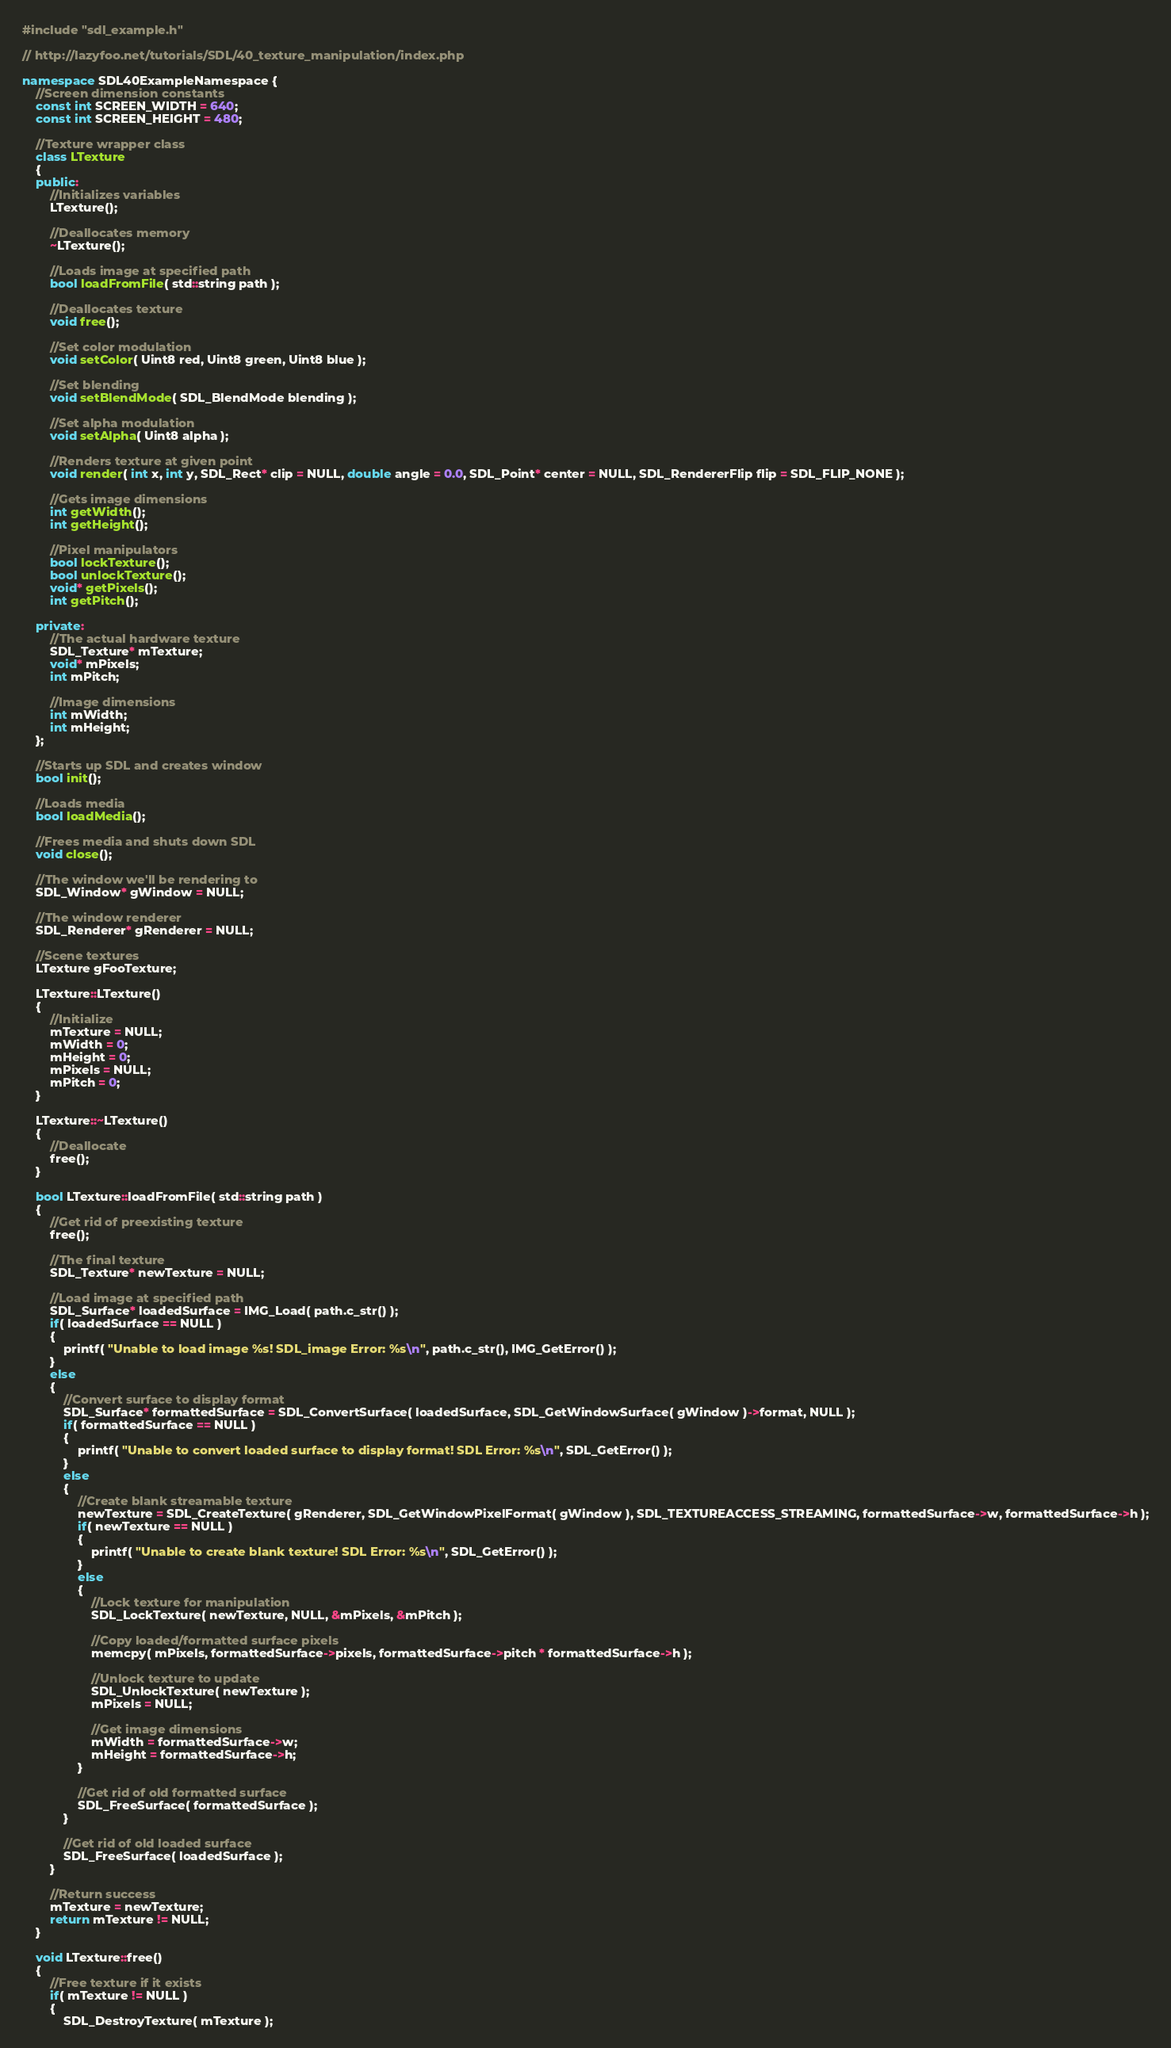Convert code to text. <code><loc_0><loc_0><loc_500><loc_500><_C++_>
#include "sdl_example.h"

// http://lazyfoo.net/tutorials/SDL/40_texture_manipulation/index.php

namespace SDL40ExampleNamespace {
    //Screen dimension constants
    const int SCREEN_WIDTH = 640;
    const int SCREEN_HEIGHT = 480;

    //Texture wrapper class
    class LTexture
    {
    public:
        //Initializes variables
        LTexture();

        //Deallocates memory
        ~LTexture();

        //Loads image at specified path
        bool loadFromFile( std::string path );

        //Deallocates texture
        void free();

        //Set color modulation
        void setColor( Uint8 red, Uint8 green, Uint8 blue );

        //Set blending
        void setBlendMode( SDL_BlendMode blending );

        //Set alpha modulation
        void setAlpha( Uint8 alpha );

        //Renders texture at given point
        void render( int x, int y, SDL_Rect* clip = NULL, double angle = 0.0, SDL_Point* center = NULL, SDL_RendererFlip flip = SDL_FLIP_NONE );

        //Gets image dimensions
        int getWidth();
        int getHeight();

        //Pixel manipulators
        bool lockTexture();
        bool unlockTexture();
        void* getPixels();
        int getPitch();

    private:
        //The actual hardware texture
        SDL_Texture* mTexture;
        void* mPixels;
        int mPitch;

        //Image dimensions
        int mWidth;
        int mHeight;
    };

    //Starts up SDL and creates window
    bool init();

    //Loads media
    bool loadMedia();

    //Frees media and shuts down SDL
    void close();

    //The window we'll be rendering to
    SDL_Window* gWindow = NULL;

    //The window renderer
    SDL_Renderer* gRenderer = NULL;

    //Scene textures
    LTexture gFooTexture;

    LTexture::LTexture()
    {
        //Initialize
        mTexture = NULL;
        mWidth = 0;
        mHeight = 0;
        mPixels = NULL;
        mPitch = 0;
    }

    LTexture::~LTexture()
    {
        //Deallocate
        free();
    }

    bool LTexture::loadFromFile( std::string path )
    {
        //Get rid of preexisting texture
        free();

        //The final texture
        SDL_Texture* newTexture = NULL;

        //Load image at specified path
        SDL_Surface* loadedSurface = IMG_Load( path.c_str() );
        if( loadedSurface == NULL )
        {
            printf( "Unable to load image %s! SDL_image Error: %s\n", path.c_str(), IMG_GetError() );
        }
        else
        {
            //Convert surface to display format
            SDL_Surface* formattedSurface = SDL_ConvertSurface( loadedSurface, SDL_GetWindowSurface( gWindow )->format, NULL );
            if( formattedSurface == NULL )
            {
                printf( "Unable to convert loaded surface to display format! SDL Error: %s\n", SDL_GetError() );
            }
            else
            {
                //Create blank streamable texture
                newTexture = SDL_CreateTexture( gRenderer, SDL_GetWindowPixelFormat( gWindow ), SDL_TEXTUREACCESS_STREAMING, formattedSurface->w, formattedSurface->h );
                if( newTexture == NULL )
                {
                    printf( "Unable to create blank texture! SDL Error: %s\n", SDL_GetError() );
                }
                else
                {
                    //Lock texture for manipulation
                    SDL_LockTexture( newTexture, NULL, &mPixels, &mPitch );

                    //Copy loaded/formatted surface pixels
                    memcpy( mPixels, formattedSurface->pixels, formattedSurface->pitch * formattedSurface->h );

                    //Unlock texture to update
                    SDL_UnlockTexture( newTexture );
                    mPixels = NULL;

                    //Get image dimensions
                    mWidth = formattedSurface->w;
                    mHeight = formattedSurface->h;
                }

                //Get rid of old formatted surface
                SDL_FreeSurface( formattedSurface );
            }

            //Get rid of old loaded surface
            SDL_FreeSurface( loadedSurface );
        }

        //Return success
        mTexture = newTexture;
        return mTexture != NULL;
    }

    void LTexture::free()
    {
        //Free texture if it exists
        if( mTexture != NULL )
        {
            SDL_DestroyTexture( mTexture );</code> 